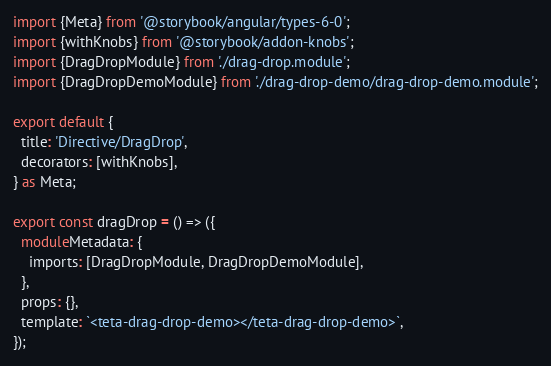Convert code to text. <code><loc_0><loc_0><loc_500><loc_500><_TypeScript_>import {Meta} from '@storybook/angular/types-6-0';
import {withKnobs} from '@storybook/addon-knobs';
import {DragDropModule} from './drag-drop.module';
import {DragDropDemoModule} from './drag-drop-demo/drag-drop-demo.module';

export default {
  title: 'Directive/DragDrop',
  decorators: [withKnobs],
} as Meta;

export const dragDrop = () => ({
  moduleMetadata: {
    imports: [DragDropModule, DragDropDemoModule],
  },
  props: {},
  template: `<teta-drag-drop-demo></teta-drag-drop-demo>`,
});
</code> 